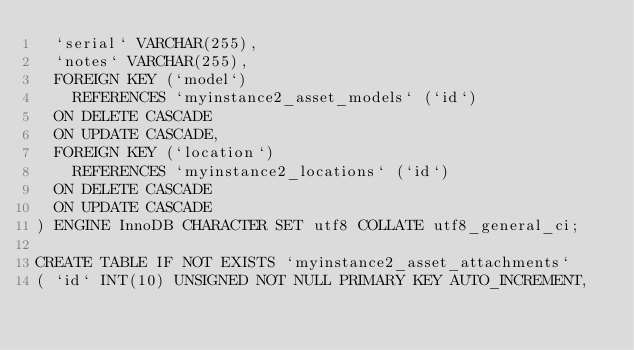Convert code to text. <code><loc_0><loc_0><loc_500><loc_500><_SQL_>  `serial` VARCHAR(255),
  `notes` VARCHAR(255),
  FOREIGN KEY (`model`)
    REFERENCES `myinstance2_asset_models` (`id`)
	ON DELETE CASCADE
	ON UPDATE CASCADE,
  FOREIGN KEY (`location`)
    REFERENCES `myinstance2_locations` (`id`)
	ON DELETE CASCADE
	ON UPDATE CASCADE
) ENGINE InnoDB CHARACTER SET utf8 COLLATE utf8_general_ci;

CREATE TABLE IF NOT EXISTS `myinstance2_asset_attachments`
( `id` INT(10) UNSIGNED NOT NULL PRIMARY KEY AUTO_INCREMENT,</code> 